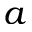Convert formula to latex. <formula><loc_0><loc_0><loc_500><loc_500>a</formula> 